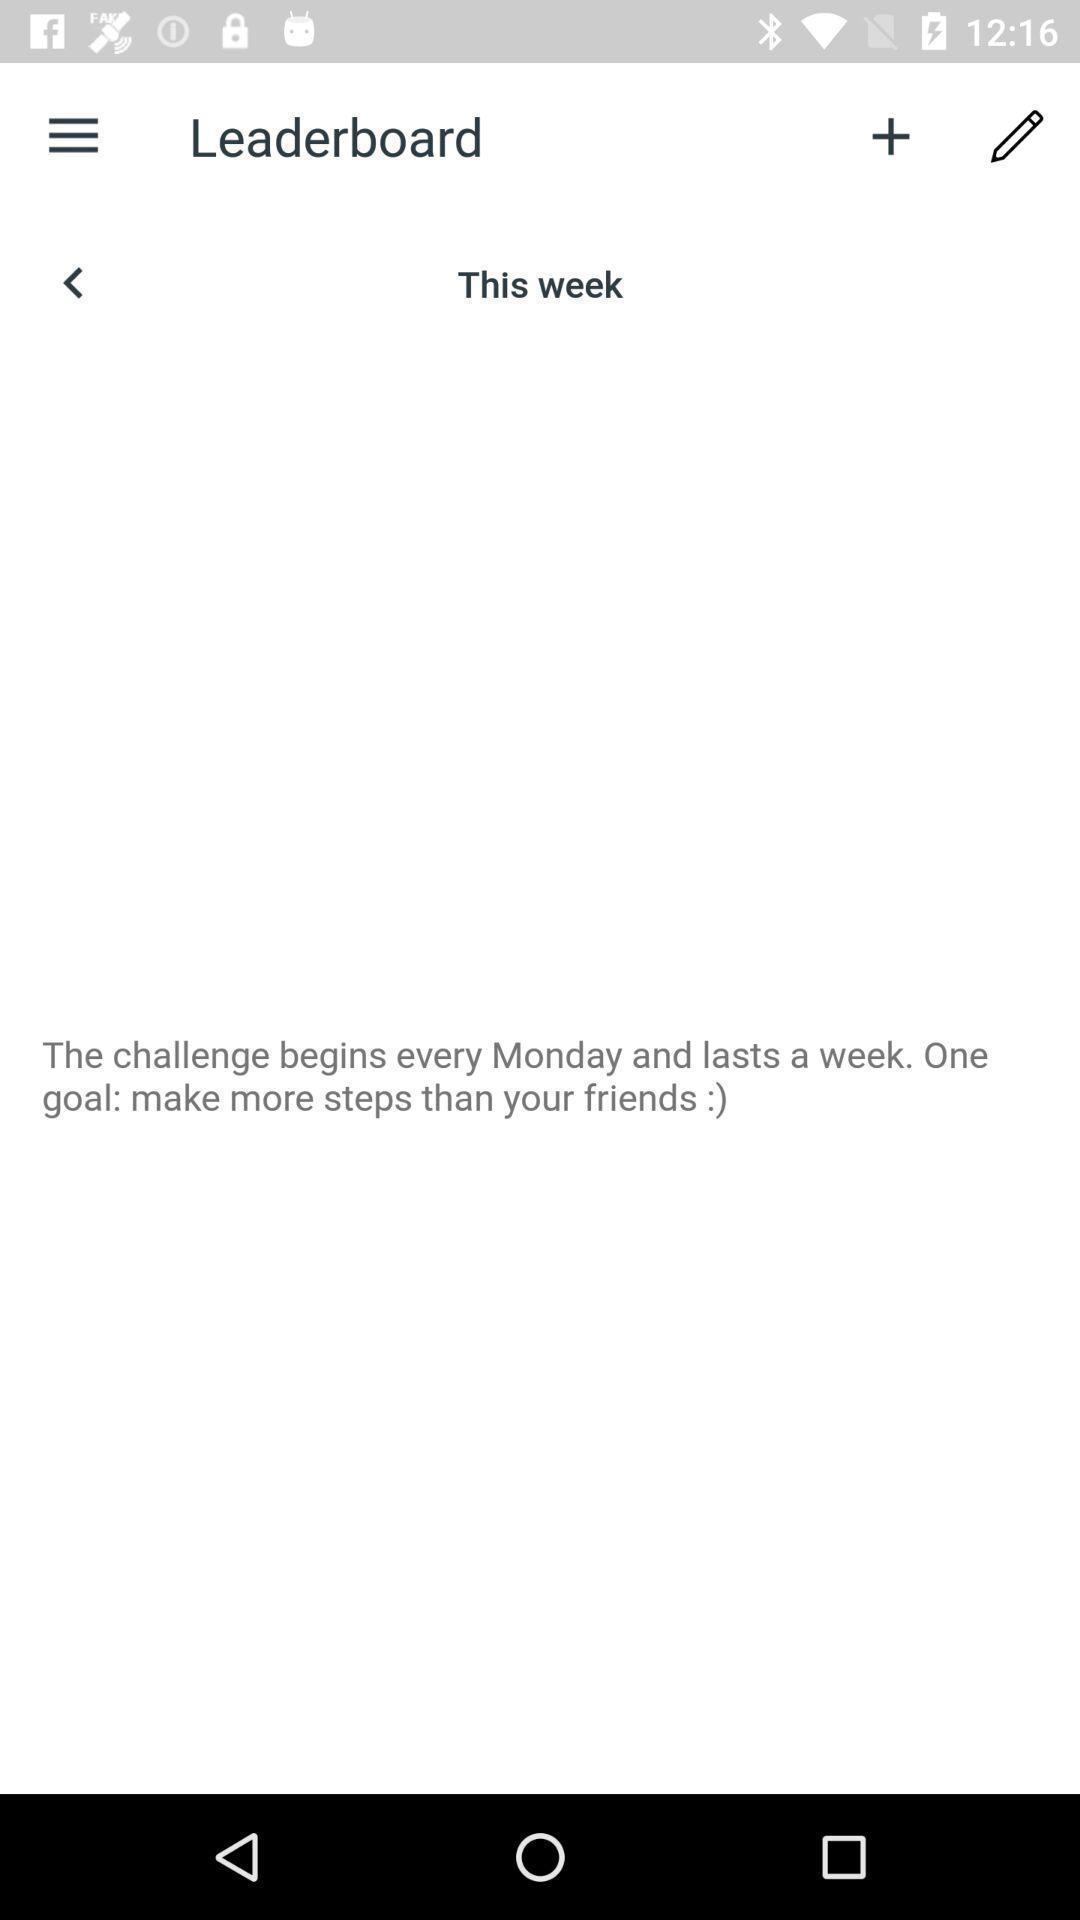Tell me about the visual elements in this screen capture. Page for adding challenges of health tracking app. 